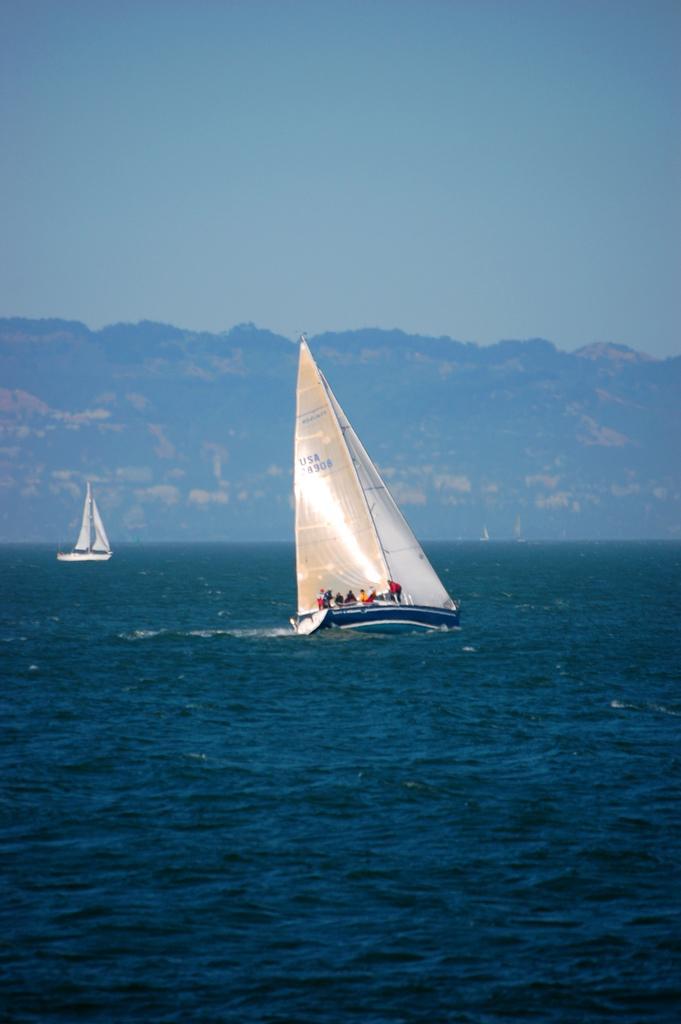In one or two sentences, can you explain what this image depicts? In the image there are two ships sailing on the sea, in the background there is a mountain. 